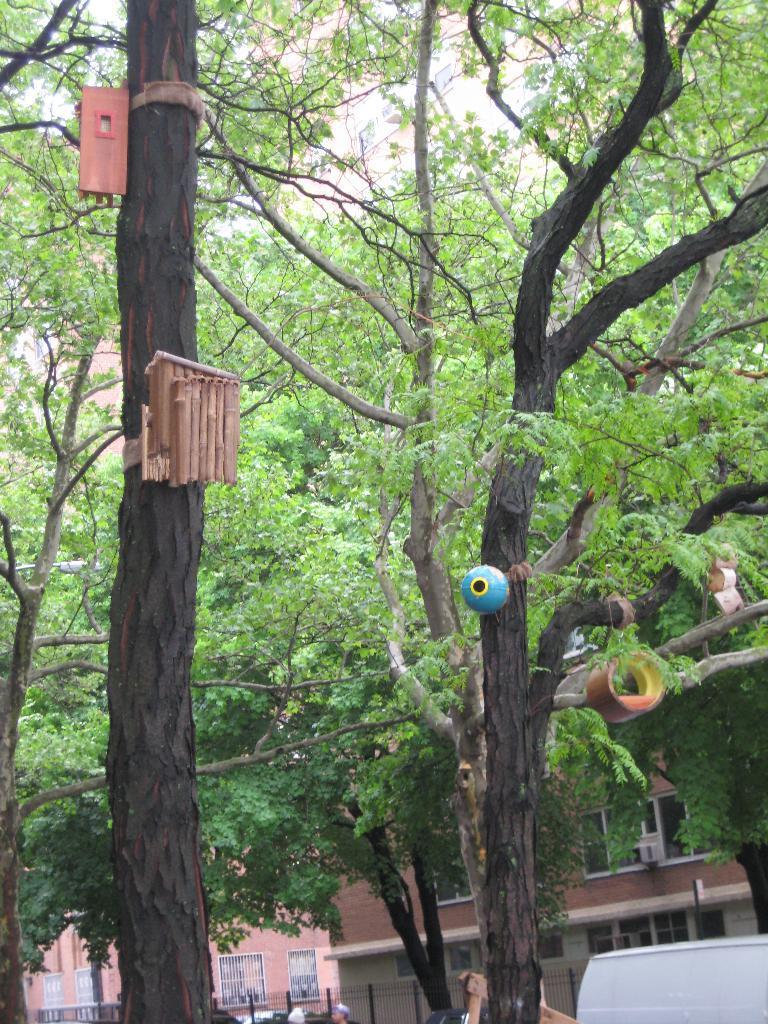In one or two sentences, can you explain what this image depicts? In this image I can see the trees in green color. I can also see few wooden objects in multi color and they are attached to the trees. Background I can see the railing and I can see few building in brown color. 